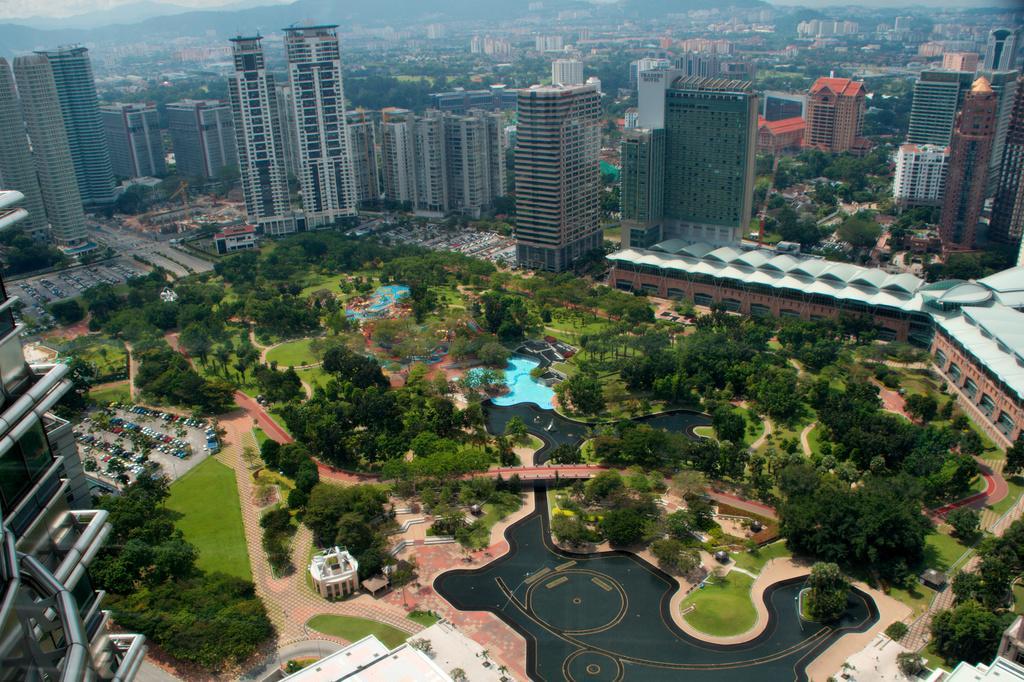In one or two sentences, can you explain what this image depicts? In this image there is a view of the city, there are buildings, there are trees, there are houses, there is a building truncated towards the left of the image, there is a building truncated towards the right of the image, there is grass, there are vehicles parked. 